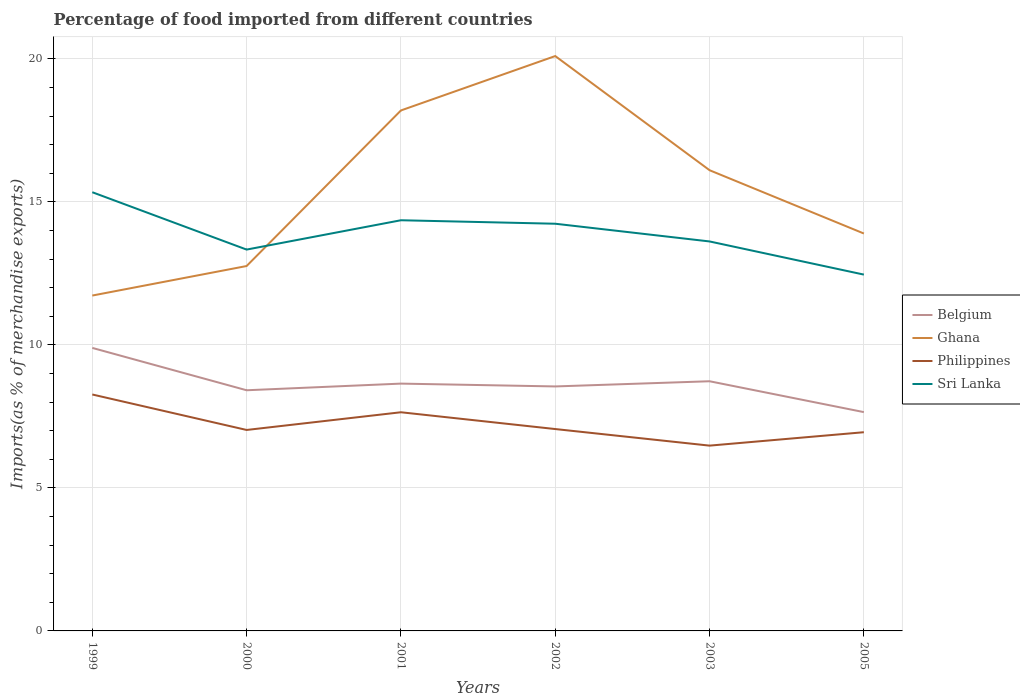Is the number of lines equal to the number of legend labels?
Offer a terse response. Yes. Across all years, what is the maximum percentage of imports to different countries in Ghana?
Provide a short and direct response. 11.73. In which year was the percentage of imports to different countries in Belgium maximum?
Your response must be concise. 2005. What is the total percentage of imports to different countries in Ghana in the graph?
Give a very brief answer. -4.38. What is the difference between the highest and the second highest percentage of imports to different countries in Ghana?
Your response must be concise. 8.37. What is the difference between the highest and the lowest percentage of imports to different countries in Belgium?
Offer a terse response. 2. How many lines are there?
Keep it short and to the point. 4. What is the difference between two consecutive major ticks on the Y-axis?
Provide a succinct answer. 5. Are the values on the major ticks of Y-axis written in scientific E-notation?
Keep it short and to the point. No. Does the graph contain any zero values?
Make the answer very short. No. What is the title of the graph?
Offer a very short reply. Percentage of food imported from different countries. Does "Albania" appear as one of the legend labels in the graph?
Your answer should be very brief. No. What is the label or title of the X-axis?
Provide a short and direct response. Years. What is the label or title of the Y-axis?
Provide a short and direct response. Imports(as % of merchandise exports). What is the Imports(as % of merchandise exports) of Belgium in 1999?
Keep it short and to the point. 9.9. What is the Imports(as % of merchandise exports) of Ghana in 1999?
Keep it short and to the point. 11.73. What is the Imports(as % of merchandise exports) in Philippines in 1999?
Provide a succinct answer. 8.27. What is the Imports(as % of merchandise exports) of Sri Lanka in 1999?
Provide a short and direct response. 15.34. What is the Imports(as % of merchandise exports) of Belgium in 2000?
Your answer should be compact. 8.42. What is the Imports(as % of merchandise exports) in Ghana in 2000?
Keep it short and to the point. 12.76. What is the Imports(as % of merchandise exports) of Philippines in 2000?
Your response must be concise. 7.03. What is the Imports(as % of merchandise exports) in Sri Lanka in 2000?
Your response must be concise. 13.33. What is the Imports(as % of merchandise exports) of Belgium in 2001?
Give a very brief answer. 8.65. What is the Imports(as % of merchandise exports) in Ghana in 2001?
Give a very brief answer. 18.2. What is the Imports(as % of merchandise exports) in Philippines in 2001?
Your answer should be compact. 7.65. What is the Imports(as % of merchandise exports) of Sri Lanka in 2001?
Offer a terse response. 14.36. What is the Imports(as % of merchandise exports) of Belgium in 2002?
Ensure brevity in your answer.  8.55. What is the Imports(as % of merchandise exports) of Ghana in 2002?
Offer a terse response. 20.1. What is the Imports(as % of merchandise exports) of Philippines in 2002?
Your response must be concise. 7.06. What is the Imports(as % of merchandise exports) in Sri Lanka in 2002?
Offer a very short reply. 14.24. What is the Imports(as % of merchandise exports) in Belgium in 2003?
Provide a succinct answer. 8.73. What is the Imports(as % of merchandise exports) of Ghana in 2003?
Give a very brief answer. 16.11. What is the Imports(as % of merchandise exports) of Philippines in 2003?
Provide a short and direct response. 6.48. What is the Imports(as % of merchandise exports) in Sri Lanka in 2003?
Your response must be concise. 13.62. What is the Imports(as % of merchandise exports) in Belgium in 2005?
Offer a very short reply. 7.65. What is the Imports(as % of merchandise exports) in Ghana in 2005?
Make the answer very short. 13.9. What is the Imports(as % of merchandise exports) in Philippines in 2005?
Give a very brief answer. 6.95. What is the Imports(as % of merchandise exports) of Sri Lanka in 2005?
Keep it short and to the point. 12.46. Across all years, what is the maximum Imports(as % of merchandise exports) of Belgium?
Give a very brief answer. 9.9. Across all years, what is the maximum Imports(as % of merchandise exports) in Ghana?
Offer a very short reply. 20.1. Across all years, what is the maximum Imports(as % of merchandise exports) of Philippines?
Make the answer very short. 8.27. Across all years, what is the maximum Imports(as % of merchandise exports) in Sri Lanka?
Offer a terse response. 15.34. Across all years, what is the minimum Imports(as % of merchandise exports) of Belgium?
Provide a short and direct response. 7.65. Across all years, what is the minimum Imports(as % of merchandise exports) in Ghana?
Your answer should be very brief. 11.73. Across all years, what is the minimum Imports(as % of merchandise exports) of Philippines?
Your answer should be compact. 6.48. Across all years, what is the minimum Imports(as % of merchandise exports) of Sri Lanka?
Ensure brevity in your answer.  12.46. What is the total Imports(as % of merchandise exports) of Belgium in the graph?
Give a very brief answer. 51.89. What is the total Imports(as % of merchandise exports) in Ghana in the graph?
Your answer should be very brief. 92.79. What is the total Imports(as % of merchandise exports) of Philippines in the graph?
Offer a very short reply. 43.43. What is the total Imports(as % of merchandise exports) in Sri Lanka in the graph?
Offer a terse response. 83.35. What is the difference between the Imports(as % of merchandise exports) in Belgium in 1999 and that in 2000?
Your answer should be compact. 1.48. What is the difference between the Imports(as % of merchandise exports) in Ghana in 1999 and that in 2000?
Make the answer very short. -1.03. What is the difference between the Imports(as % of merchandise exports) of Philippines in 1999 and that in 2000?
Provide a short and direct response. 1.24. What is the difference between the Imports(as % of merchandise exports) in Sri Lanka in 1999 and that in 2000?
Your response must be concise. 2.01. What is the difference between the Imports(as % of merchandise exports) of Belgium in 1999 and that in 2001?
Your response must be concise. 1.25. What is the difference between the Imports(as % of merchandise exports) in Ghana in 1999 and that in 2001?
Your answer should be compact. -6.47. What is the difference between the Imports(as % of merchandise exports) in Philippines in 1999 and that in 2001?
Keep it short and to the point. 0.62. What is the difference between the Imports(as % of merchandise exports) in Belgium in 1999 and that in 2002?
Your response must be concise. 1.35. What is the difference between the Imports(as % of merchandise exports) in Ghana in 1999 and that in 2002?
Ensure brevity in your answer.  -8.37. What is the difference between the Imports(as % of merchandise exports) of Philippines in 1999 and that in 2002?
Provide a succinct answer. 1.21. What is the difference between the Imports(as % of merchandise exports) of Sri Lanka in 1999 and that in 2002?
Give a very brief answer. 1.1. What is the difference between the Imports(as % of merchandise exports) in Belgium in 1999 and that in 2003?
Ensure brevity in your answer.  1.17. What is the difference between the Imports(as % of merchandise exports) of Ghana in 1999 and that in 2003?
Give a very brief answer. -4.38. What is the difference between the Imports(as % of merchandise exports) of Philippines in 1999 and that in 2003?
Provide a succinct answer. 1.79. What is the difference between the Imports(as % of merchandise exports) in Sri Lanka in 1999 and that in 2003?
Offer a terse response. 1.72. What is the difference between the Imports(as % of merchandise exports) in Belgium in 1999 and that in 2005?
Offer a terse response. 2.25. What is the difference between the Imports(as % of merchandise exports) in Ghana in 1999 and that in 2005?
Keep it short and to the point. -2.17. What is the difference between the Imports(as % of merchandise exports) of Philippines in 1999 and that in 2005?
Give a very brief answer. 1.32. What is the difference between the Imports(as % of merchandise exports) in Sri Lanka in 1999 and that in 2005?
Your response must be concise. 2.88. What is the difference between the Imports(as % of merchandise exports) of Belgium in 2000 and that in 2001?
Keep it short and to the point. -0.23. What is the difference between the Imports(as % of merchandise exports) of Ghana in 2000 and that in 2001?
Offer a very short reply. -5.44. What is the difference between the Imports(as % of merchandise exports) in Philippines in 2000 and that in 2001?
Make the answer very short. -0.62. What is the difference between the Imports(as % of merchandise exports) in Sri Lanka in 2000 and that in 2001?
Make the answer very short. -1.03. What is the difference between the Imports(as % of merchandise exports) in Belgium in 2000 and that in 2002?
Make the answer very short. -0.13. What is the difference between the Imports(as % of merchandise exports) in Ghana in 2000 and that in 2002?
Provide a succinct answer. -7.34. What is the difference between the Imports(as % of merchandise exports) in Philippines in 2000 and that in 2002?
Offer a very short reply. -0.03. What is the difference between the Imports(as % of merchandise exports) of Sri Lanka in 2000 and that in 2002?
Your answer should be compact. -0.9. What is the difference between the Imports(as % of merchandise exports) in Belgium in 2000 and that in 2003?
Provide a succinct answer. -0.32. What is the difference between the Imports(as % of merchandise exports) of Ghana in 2000 and that in 2003?
Keep it short and to the point. -3.35. What is the difference between the Imports(as % of merchandise exports) of Philippines in 2000 and that in 2003?
Ensure brevity in your answer.  0.55. What is the difference between the Imports(as % of merchandise exports) in Sri Lanka in 2000 and that in 2003?
Provide a succinct answer. -0.28. What is the difference between the Imports(as % of merchandise exports) of Belgium in 2000 and that in 2005?
Provide a short and direct response. 0.76. What is the difference between the Imports(as % of merchandise exports) of Ghana in 2000 and that in 2005?
Your answer should be compact. -1.14. What is the difference between the Imports(as % of merchandise exports) in Philippines in 2000 and that in 2005?
Offer a terse response. 0.08. What is the difference between the Imports(as % of merchandise exports) in Sri Lanka in 2000 and that in 2005?
Your answer should be compact. 0.87. What is the difference between the Imports(as % of merchandise exports) in Belgium in 2001 and that in 2002?
Offer a terse response. 0.1. What is the difference between the Imports(as % of merchandise exports) of Ghana in 2001 and that in 2002?
Your response must be concise. -1.9. What is the difference between the Imports(as % of merchandise exports) of Philippines in 2001 and that in 2002?
Provide a succinct answer. 0.59. What is the difference between the Imports(as % of merchandise exports) of Sri Lanka in 2001 and that in 2002?
Provide a short and direct response. 0.12. What is the difference between the Imports(as % of merchandise exports) of Belgium in 2001 and that in 2003?
Offer a very short reply. -0.08. What is the difference between the Imports(as % of merchandise exports) of Ghana in 2001 and that in 2003?
Your answer should be compact. 2.09. What is the difference between the Imports(as % of merchandise exports) of Sri Lanka in 2001 and that in 2003?
Your answer should be very brief. 0.74. What is the difference between the Imports(as % of merchandise exports) in Belgium in 2001 and that in 2005?
Ensure brevity in your answer.  1. What is the difference between the Imports(as % of merchandise exports) of Ghana in 2001 and that in 2005?
Offer a terse response. 4.3. What is the difference between the Imports(as % of merchandise exports) in Philippines in 2001 and that in 2005?
Make the answer very short. 0.7. What is the difference between the Imports(as % of merchandise exports) of Sri Lanka in 2001 and that in 2005?
Your answer should be compact. 1.9. What is the difference between the Imports(as % of merchandise exports) in Belgium in 2002 and that in 2003?
Make the answer very short. -0.18. What is the difference between the Imports(as % of merchandise exports) in Ghana in 2002 and that in 2003?
Your answer should be very brief. 3.99. What is the difference between the Imports(as % of merchandise exports) of Philippines in 2002 and that in 2003?
Provide a succinct answer. 0.58. What is the difference between the Imports(as % of merchandise exports) of Sri Lanka in 2002 and that in 2003?
Offer a very short reply. 0.62. What is the difference between the Imports(as % of merchandise exports) of Belgium in 2002 and that in 2005?
Provide a short and direct response. 0.9. What is the difference between the Imports(as % of merchandise exports) in Ghana in 2002 and that in 2005?
Ensure brevity in your answer.  6.21. What is the difference between the Imports(as % of merchandise exports) in Philippines in 2002 and that in 2005?
Offer a very short reply. 0.11. What is the difference between the Imports(as % of merchandise exports) in Sri Lanka in 2002 and that in 2005?
Your answer should be compact. 1.78. What is the difference between the Imports(as % of merchandise exports) of Belgium in 2003 and that in 2005?
Give a very brief answer. 1.08. What is the difference between the Imports(as % of merchandise exports) of Ghana in 2003 and that in 2005?
Offer a terse response. 2.21. What is the difference between the Imports(as % of merchandise exports) in Philippines in 2003 and that in 2005?
Your response must be concise. -0.47. What is the difference between the Imports(as % of merchandise exports) in Sri Lanka in 2003 and that in 2005?
Your answer should be very brief. 1.16. What is the difference between the Imports(as % of merchandise exports) in Belgium in 1999 and the Imports(as % of merchandise exports) in Ghana in 2000?
Keep it short and to the point. -2.86. What is the difference between the Imports(as % of merchandise exports) of Belgium in 1999 and the Imports(as % of merchandise exports) of Philippines in 2000?
Your answer should be very brief. 2.87. What is the difference between the Imports(as % of merchandise exports) of Belgium in 1999 and the Imports(as % of merchandise exports) of Sri Lanka in 2000?
Provide a succinct answer. -3.44. What is the difference between the Imports(as % of merchandise exports) of Ghana in 1999 and the Imports(as % of merchandise exports) of Philippines in 2000?
Your answer should be very brief. 4.7. What is the difference between the Imports(as % of merchandise exports) in Ghana in 1999 and the Imports(as % of merchandise exports) in Sri Lanka in 2000?
Make the answer very short. -1.61. What is the difference between the Imports(as % of merchandise exports) in Philippines in 1999 and the Imports(as % of merchandise exports) in Sri Lanka in 2000?
Keep it short and to the point. -5.07. What is the difference between the Imports(as % of merchandise exports) in Belgium in 1999 and the Imports(as % of merchandise exports) in Ghana in 2001?
Provide a succinct answer. -8.3. What is the difference between the Imports(as % of merchandise exports) of Belgium in 1999 and the Imports(as % of merchandise exports) of Philippines in 2001?
Ensure brevity in your answer.  2.25. What is the difference between the Imports(as % of merchandise exports) of Belgium in 1999 and the Imports(as % of merchandise exports) of Sri Lanka in 2001?
Make the answer very short. -4.46. What is the difference between the Imports(as % of merchandise exports) of Ghana in 1999 and the Imports(as % of merchandise exports) of Philippines in 2001?
Ensure brevity in your answer.  4.08. What is the difference between the Imports(as % of merchandise exports) of Ghana in 1999 and the Imports(as % of merchandise exports) of Sri Lanka in 2001?
Make the answer very short. -2.63. What is the difference between the Imports(as % of merchandise exports) in Philippines in 1999 and the Imports(as % of merchandise exports) in Sri Lanka in 2001?
Make the answer very short. -6.09. What is the difference between the Imports(as % of merchandise exports) in Belgium in 1999 and the Imports(as % of merchandise exports) in Ghana in 2002?
Provide a short and direct response. -10.21. What is the difference between the Imports(as % of merchandise exports) in Belgium in 1999 and the Imports(as % of merchandise exports) in Philippines in 2002?
Offer a very short reply. 2.84. What is the difference between the Imports(as % of merchandise exports) in Belgium in 1999 and the Imports(as % of merchandise exports) in Sri Lanka in 2002?
Give a very brief answer. -4.34. What is the difference between the Imports(as % of merchandise exports) of Ghana in 1999 and the Imports(as % of merchandise exports) of Philippines in 2002?
Make the answer very short. 4.67. What is the difference between the Imports(as % of merchandise exports) of Ghana in 1999 and the Imports(as % of merchandise exports) of Sri Lanka in 2002?
Your response must be concise. -2.51. What is the difference between the Imports(as % of merchandise exports) of Philippines in 1999 and the Imports(as % of merchandise exports) of Sri Lanka in 2002?
Offer a terse response. -5.97. What is the difference between the Imports(as % of merchandise exports) in Belgium in 1999 and the Imports(as % of merchandise exports) in Ghana in 2003?
Your answer should be compact. -6.21. What is the difference between the Imports(as % of merchandise exports) of Belgium in 1999 and the Imports(as % of merchandise exports) of Philippines in 2003?
Offer a terse response. 3.42. What is the difference between the Imports(as % of merchandise exports) of Belgium in 1999 and the Imports(as % of merchandise exports) of Sri Lanka in 2003?
Your answer should be very brief. -3.72. What is the difference between the Imports(as % of merchandise exports) of Ghana in 1999 and the Imports(as % of merchandise exports) of Philippines in 2003?
Give a very brief answer. 5.25. What is the difference between the Imports(as % of merchandise exports) in Ghana in 1999 and the Imports(as % of merchandise exports) in Sri Lanka in 2003?
Keep it short and to the point. -1.89. What is the difference between the Imports(as % of merchandise exports) in Philippines in 1999 and the Imports(as % of merchandise exports) in Sri Lanka in 2003?
Ensure brevity in your answer.  -5.35. What is the difference between the Imports(as % of merchandise exports) in Belgium in 1999 and the Imports(as % of merchandise exports) in Ghana in 2005?
Ensure brevity in your answer.  -4. What is the difference between the Imports(as % of merchandise exports) in Belgium in 1999 and the Imports(as % of merchandise exports) in Philippines in 2005?
Give a very brief answer. 2.95. What is the difference between the Imports(as % of merchandise exports) of Belgium in 1999 and the Imports(as % of merchandise exports) of Sri Lanka in 2005?
Your answer should be very brief. -2.56. What is the difference between the Imports(as % of merchandise exports) in Ghana in 1999 and the Imports(as % of merchandise exports) in Philippines in 2005?
Keep it short and to the point. 4.78. What is the difference between the Imports(as % of merchandise exports) in Ghana in 1999 and the Imports(as % of merchandise exports) in Sri Lanka in 2005?
Make the answer very short. -0.73. What is the difference between the Imports(as % of merchandise exports) in Philippines in 1999 and the Imports(as % of merchandise exports) in Sri Lanka in 2005?
Provide a short and direct response. -4.19. What is the difference between the Imports(as % of merchandise exports) in Belgium in 2000 and the Imports(as % of merchandise exports) in Ghana in 2001?
Provide a short and direct response. -9.78. What is the difference between the Imports(as % of merchandise exports) of Belgium in 2000 and the Imports(as % of merchandise exports) of Philippines in 2001?
Offer a terse response. 0.77. What is the difference between the Imports(as % of merchandise exports) in Belgium in 2000 and the Imports(as % of merchandise exports) in Sri Lanka in 2001?
Provide a succinct answer. -5.94. What is the difference between the Imports(as % of merchandise exports) of Ghana in 2000 and the Imports(as % of merchandise exports) of Philippines in 2001?
Offer a terse response. 5.11. What is the difference between the Imports(as % of merchandise exports) of Ghana in 2000 and the Imports(as % of merchandise exports) of Sri Lanka in 2001?
Offer a terse response. -1.6. What is the difference between the Imports(as % of merchandise exports) in Philippines in 2000 and the Imports(as % of merchandise exports) in Sri Lanka in 2001?
Offer a terse response. -7.33. What is the difference between the Imports(as % of merchandise exports) of Belgium in 2000 and the Imports(as % of merchandise exports) of Ghana in 2002?
Give a very brief answer. -11.69. What is the difference between the Imports(as % of merchandise exports) of Belgium in 2000 and the Imports(as % of merchandise exports) of Philippines in 2002?
Make the answer very short. 1.36. What is the difference between the Imports(as % of merchandise exports) of Belgium in 2000 and the Imports(as % of merchandise exports) of Sri Lanka in 2002?
Make the answer very short. -5.82. What is the difference between the Imports(as % of merchandise exports) in Ghana in 2000 and the Imports(as % of merchandise exports) in Philippines in 2002?
Your answer should be compact. 5.7. What is the difference between the Imports(as % of merchandise exports) in Ghana in 2000 and the Imports(as % of merchandise exports) in Sri Lanka in 2002?
Make the answer very short. -1.48. What is the difference between the Imports(as % of merchandise exports) in Philippines in 2000 and the Imports(as % of merchandise exports) in Sri Lanka in 2002?
Your answer should be very brief. -7.21. What is the difference between the Imports(as % of merchandise exports) in Belgium in 2000 and the Imports(as % of merchandise exports) in Ghana in 2003?
Make the answer very short. -7.69. What is the difference between the Imports(as % of merchandise exports) of Belgium in 2000 and the Imports(as % of merchandise exports) of Philippines in 2003?
Offer a very short reply. 1.94. What is the difference between the Imports(as % of merchandise exports) of Belgium in 2000 and the Imports(as % of merchandise exports) of Sri Lanka in 2003?
Your answer should be compact. -5.2. What is the difference between the Imports(as % of merchandise exports) in Ghana in 2000 and the Imports(as % of merchandise exports) in Philippines in 2003?
Ensure brevity in your answer.  6.28. What is the difference between the Imports(as % of merchandise exports) of Ghana in 2000 and the Imports(as % of merchandise exports) of Sri Lanka in 2003?
Keep it short and to the point. -0.86. What is the difference between the Imports(as % of merchandise exports) in Philippines in 2000 and the Imports(as % of merchandise exports) in Sri Lanka in 2003?
Your response must be concise. -6.59. What is the difference between the Imports(as % of merchandise exports) in Belgium in 2000 and the Imports(as % of merchandise exports) in Ghana in 2005?
Ensure brevity in your answer.  -5.48. What is the difference between the Imports(as % of merchandise exports) of Belgium in 2000 and the Imports(as % of merchandise exports) of Philippines in 2005?
Your response must be concise. 1.47. What is the difference between the Imports(as % of merchandise exports) in Belgium in 2000 and the Imports(as % of merchandise exports) in Sri Lanka in 2005?
Your answer should be compact. -4.04. What is the difference between the Imports(as % of merchandise exports) in Ghana in 2000 and the Imports(as % of merchandise exports) in Philippines in 2005?
Provide a succinct answer. 5.81. What is the difference between the Imports(as % of merchandise exports) of Ghana in 2000 and the Imports(as % of merchandise exports) of Sri Lanka in 2005?
Ensure brevity in your answer.  0.3. What is the difference between the Imports(as % of merchandise exports) in Philippines in 2000 and the Imports(as % of merchandise exports) in Sri Lanka in 2005?
Ensure brevity in your answer.  -5.43. What is the difference between the Imports(as % of merchandise exports) of Belgium in 2001 and the Imports(as % of merchandise exports) of Ghana in 2002?
Provide a short and direct response. -11.45. What is the difference between the Imports(as % of merchandise exports) in Belgium in 2001 and the Imports(as % of merchandise exports) in Philippines in 2002?
Provide a short and direct response. 1.59. What is the difference between the Imports(as % of merchandise exports) of Belgium in 2001 and the Imports(as % of merchandise exports) of Sri Lanka in 2002?
Give a very brief answer. -5.59. What is the difference between the Imports(as % of merchandise exports) of Ghana in 2001 and the Imports(as % of merchandise exports) of Philippines in 2002?
Ensure brevity in your answer.  11.14. What is the difference between the Imports(as % of merchandise exports) of Ghana in 2001 and the Imports(as % of merchandise exports) of Sri Lanka in 2002?
Your answer should be very brief. 3.96. What is the difference between the Imports(as % of merchandise exports) in Philippines in 2001 and the Imports(as % of merchandise exports) in Sri Lanka in 2002?
Offer a very short reply. -6.59. What is the difference between the Imports(as % of merchandise exports) of Belgium in 2001 and the Imports(as % of merchandise exports) of Ghana in 2003?
Keep it short and to the point. -7.46. What is the difference between the Imports(as % of merchandise exports) in Belgium in 2001 and the Imports(as % of merchandise exports) in Philippines in 2003?
Your answer should be very brief. 2.17. What is the difference between the Imports(as % of merchandise exports) in Belgium in 2001 and the Imports(as % of merchandise exports) in Sri Lanka in 2003?
Give a very brief answer. -4.97. What is the difference between the Imports(as % of merchandise exports) of Ghana in 2001 and the Imports(as % of merchandise exports) of Philippines in 2003?
Provide a short and direct response. 11.72. What is the difference between the Imports(as % of merchandise exports) of Ghana in 2001 and the Imports(as % of merchandise exports) of Sri Lanka in 2003?
Offer a terse response. 4.58. What is the difference between the Imports(as % of merchandise exports) in Philippines in 2001 and the Imports(as % of merchandise exports) in Sri Lanka in 2003?
Offer a very short reply. -5.97. What is the difference between the Imports(as % of merchandise exports) in Belgium in 2001 and the Imports(as % of merchandise exports) in Ghana in 2005?
Ensure brevity in your answer.  -5.25. What is the difference between the Imports(as % of merchandise exports) of Belgium in 2001 and the Imports(as % of merchandise exports) of Philippines in 2005?
Make the answer very short. 1.7. What is the difference between the Imports(as % of merchandise exports) in Belgium in 2001 and the Imports(as % of merchandise exports) in Sri Lanka in 2005?
Offer a very short reply. -3.81. What is the difference between the Imports(as % of merchandise exports) of Ghana in 2001 and the Imports(as % of merchandise exports) of Philippines in 2005?
Give a very brief answer. 11.25. What is the difference between the Imports(as % of merchandise exports) of Ghana in 2001 and the Imports(as % of merchandise exports) of Sri Lanka in 2005?
Offer a terse response. 5.74. What is the difference between the Imports(as % of merchandise exports) of Philippines in 2001 and the Imports(as % of merchandise exports) of Sri Lanka in 2005?
Your answer should be very brief. -4.81. What is the difference between the Imports(as % of merchandise exports) of Belgium in 2002 and the Imports(as % of merchandise exports) of Ghana in 2003?
Provide a short and direct response. -7.56. What is the difference between the Imports(as % of merchandise exports) of Belgium in 2002 and the Imports(as % of merchandise exports) of Philippines in 2003?
Provide a short and direct response. 2.07. What is the difference between the Imports(as % of merchandise exports) in Belgium in 2002 and the Imports(as % of merchandise exports) in Sri Lanka in 2003?
Your answer should be very brief. -5.07. What is the difference between the Imports(as % of merchandise exports) in Ghana in 2002 and the Imports(as % of merchandise exports) in Philippines in 2003?
Offer a very short reply. 13.62. What is the difference between the Imports(as % of merchandise exports) of Ghana in 2002 and the Imports(as % of merchandise exports) of Sri Lanka in 2003?
Ensure brevity in your answer.  6.48. What is the difference between the Imports(as % of merchandise exports) of Philippines in 2002 and the Imports(as % of merchandise exports) of Sri Lanka in 2003?
Keep it short and to the point. -6.56. What is the difference between the Imports(as % of merchandise exports) of Belgium in 2002 and the Imports(as % of merchandise exports) of Ghana in 2005?
Offer a very short reply. -5.35. What is the difference between the Imports(as % of merchandise exports) in Belgium in 2002 and the Imports(as % of merchandise exports) in Philippines in 2005?
Your answer should be very brief. 1.6. What is the difference between the Imports(as % of merchandise exports) in Belgium in 2002 and the Imports(as % of merchandise exports) in Sri Lanka in 2005?
Ensure brevity in your answer.  -3.91. What is the difference between the Imports(as % of merchandise exports) of Ghana in 2002 and the Imports(as % of merchandise exports) of Philippines in 2005?
Offer a very short reply. 13.15. What is the difference between the Imports(as % of merchandise exports) of Ghana in 2002 and the Imports(as % of merchandise exports) of Sri Lanka in 2005?
Keep it short and to the point. 7.64. What is the difference between the Imports(as % of merchandise exports) of Philippines in 2002 and the Imports(as % of merchandise exports) of Sri Lanka in 2005?
Your answer should be compact. -5.4. What is the difference between the Imports(as % of merchandise exports) in Belgium in 2003 and the Imports(as % of merchandise exports) in Ghana in 2005?
Ensure brevity in your answer.  -5.17. What is the difference between the Imports(as % of merchandise exports) of Belgium in 2003 and the Imports(as % of merchandise exports) of Philippines in 2005?
Provide a succinct answer. 1.78. What is the difference between the Imports(as % of merchandise exports) of Belgium in 2003 and the Imports(as % of merchandise exports) of Sri Lanka in 2005?
Ensure brevity in your answer.  -3.73. What is the difference between the Imports(as % of merchandise exports) of Ghana in 2003 and the Imports(as % of merchandise exports) of Philippines in 2005?
Offer a terse response. 9.16. What is the difference between the Imports(as % of merchandise exports) of Ghana in 2003 and the Imports(as % of merchandise exports) of Sri Lanka in 2005?
Your response must be concise. 3.65. What is the difference between the Imports(as % of merchandise exports) of Philippines in 2003 and the Imports(as % of merchandise exports) of Sri Lanka in 2005?
Your answer should be very brief. -5.98. What is the average Imports(as % of merchandise exports) in Belgium per year?
Your response must be concise. 8.65. What is the average Imports(as % of merchandise exports) in Ghana per year?
Provide a succinct answer. 15.47. What is the average Imports(as % of merchandise exports) in Philippines per year?
Offer a very short reply. 7.24. What is the average Imports(as % of merchandise exports) of Sri Lanka per year?
Provide a short and direct response. 13.89. In the year 1999, what is the difference between the Imports(as % of merchandise exports) in Belgium and Imports(as % of merchandise exports) in Ghana?
Make the answer very short. -1.83. In the year 1999, what is the difference between the Imports(as % of merchandise exports) of Belgium and Imports(as % of merchandise exports) of Philippines?
Provide a succinct answer. 1.63. In the year 1999, what is the difference between the Imports(as % of merchandise exports) of Belgium and Imports(as % of merchandise exports) of Sri Lanka?
Provide a short and direct response. -5.44. In the year 1999, what is the difference between the Imports(as % of merchandise exports) of Ghana and Imports(as % of merchandise exports) of Philippines?
Ensure brevity in your answer.  3.46. In the year 1999, what is the difference between the Imports(as % of merchandise exports) in Ghana and Imports(as % of merchandise exports) in Sri Lanka?
Your answer should be very brief. -3.61. In the year 1999, what is the difference between the Imports(as % of merchandise exports) in Philippines and Imports(as % of merchandise exports) in Sri Lanka?
Offer a terse response. -7.07. In the year 2000, what is the difference between the Imports(as % of merchandise exports) of Belgium and Imports(as % of merchandise exports) of Ghana?
Make the answer very short. -4.34. In the year 2000, what is the difference between the Imports(as % of merchandise exports) in Belgium and Imports(as % of merchandise exports) in Philippines?
Offer a terse response. 1.39. In the year 2000, what is the difference between the Imports(as % of merchandise exports) in Belgium and Imports(as % of merchandise exports) in Sri Lanka?
Your answer should be compact. -4.92. In the year 2000, what is the difference between the Imports(as % of merchandise exports) of Ghana and Imports(as % of merchandise exports) of Philippines?
Provide a short and direct response. 5.73. In the year 2000, what is the difference between the Imports(as % of merchandise exports) in Ghana and Imports(as % of merchandise exports) in Sri Lanka?
Provide a succinct answer. -0.57. In the year 2000, what is the difference between the Imports(as % of merchandise exports) of Philippines and Imports(as % of merchandise exports) of Sri Lanka?
Provide a succinct answer. -6.31. In the year 2001, what is the difference between the Imports(as % of merchandise exports) of Belgium and Imports(as % of merchandise exports) of Ghana?
Give a very brief answer. -9.55. In the year 2001, what is the difference between the Imports(as % of merchandise exports) of Belgium and Imports(as % of merchandise exports) of Philippines?
Provide a succinct answer. 1. In the year 2001, what is the difference between the Imports(as % of merchandise exports) of Belgium and Imports(as % of merchandise exports) of Sri Lanka?
Give a very brief answer. -5.71. In the year 2001, what is the difference between the Imports(as % of merchandise exports) in Ghana and Imports(as % of merchandise exports) in Philippines?
Ensure brevity in your answer.  10.55. In the year 2001, what is the difference between the Imports(as % of merchandise exports) of Ghana and Imports(as % of merchandise exports) of Sri Lanka?
Offer a very short reply. 3.84. In the year 2001, what is the difference between the Imports(as % of merchandise exports) of Philippines and Imports(as % of merchandise exports) of Sri Lanka?
Keep it short and to the point. -6.71. In the year 2002, what is the difference between the Imports(as % of merchandise exports) of Belgium and Imports(as % of merchandise exports) of Ghana?
Offer a terse response. -11.55. In the year 2002, what is the difference between the Imports(as % of merchandise exports) of Belgium and Imports(as % of merchandise exports) of Philippines?
Give a very brief answer. 1.49. In the year 2002, what is the difference between the Imports(as % of merchandise exports) of Belgium and Imports(as % of merchandise exports) of Sri Lanka?
Make the answer very short. -5.69. In the year 2002, what is the difference between the Imports(as % of merchandise exports) in Ghana and Imports(as % of merchandise exports) in Philippines?
Offer a terse response. 13.04. In the year 2002, what is the difference between the Imports(as % of merchandise exports) of Ghana and Imports(as % of merchandise exports) of Sri Lanka?
Make the answer very short. 5.86. In the year 2002, what is the difference between the Imports(as % of merchandise exports) in Philippines and Imports(as % of merchandise exports) in Sri Lanka?
Offer a terse response. -7.18. In the year 2003, what is the difference between the Imports(as % of merchandise exports) of Belgium and Imports(as % of merchandise exports) of Ghana?
Offer a very short reply. -7.38. In the year 2003, what is the difference between the Imports(as % of merchandise exports) of Belgium and Imports(as % of merchandise exports) of Philippines?
Provide a succinct answer. 2.25. In the year 2003, what is the difference between the Imports(as % of merchandise exports) of Belgium and Imports(as % of merchandise exports) of Sri Lanka?
Ensure brevity in your answer.  -4.89. In the year 2003, what is the difference between the Imports(as % of merchandise exports) of Ghana and Imports(as % of merchandise exports) of Philippines?
Ensure brevity in your answer.  9.63. In the year 2003, what is the difference between the Imports(as % of merchandise exports) of Ghana and Imports(as % of merchandise exports) of Sri Lanka?
Give a very brief answer. 2.49. In the year 2003, what is the difference between the Imports(as % of merchandise exports) in Philippines and Imports(as % of merchandise exports) in Sri Lanka?
Provide a succinct answer. -7.14. In the year 2005, what is the difference between the Imports(as % of merchandise exports) in Belgium and Imports(as % of merchandise exports) in Ghana?
Provide a short and direct response. -6.25. In the year 2005, what is the difference between the Imports(as % of merchandise exports) of Belgium and Imports(as % of merchandise exports) of Philippines?
Keep it short and to the point. 0.7. In the year 2005, what is the difference between the Imports(as % of merchandise exports) of Belgium and Imports(as % of merchandise exports) of Sri Lanka?
Your answer should be very brief. -4.81. In the year 2005, what is the difference between the Imports(as % of merchandise exports) in Ghana and Imports(as % of merchandise exports) in Philippines?
Keep it short and to the point. 6.95. In the year 2005, what is the difference between the Imports(as % of merchandise exports) in Ghana and Imports(as % of merchandise exports) in Sri Lanka?
Make the answer very short. 1.44. In the year 2005, what is the difference between the Imports(as % of merchandise exports) in Philippines and Imports(as % of merchandise exports) in Sri Lanka?
Your answer should be compact. -5.51. What is the ratio of the Imports(as % of merchandise exports) in Belgium in 1999 to that in 2000?
Your answer should be compact. 1.18. What is the ratio of the Imports(as % of merchandise exports) of Ghana in 1999 to that in 2000?
Offer a very short reply. 0.92. What is the ratio of the Imports(as % of merchandise exports) of Philippines in 1999 to that in 2000?
Keep it short and to the point. 1.18. What is the ratio of the Imports(as % of merchandise exports) in Sri Lanka in 1999 to that in 2000?
Your response must be concise. 1.15. What is the ratio of the Imports(as % of merchandise exports) of Belgium in 1999 to that in 2001?
Provide a succinct answer. 1.14. What is the ratio of the Imports(as % of merchandise exports) in Ghana in 1999 to that in 2001?
Give a very brief answer. 0.64. What is the ratio of the Imports(as % of merchandise exports) of Philippines in 1999 to that in 2001?
Offer a very short reply. 1.08. What is the ratio of the Imports(as % of merchandise exports) of Sri Lanka in 1999 to that in 2001?
Make the answer very short. 1.07. What is the ratio of the Imports(as % of merchandise exports) of Belgium in 1999 to that in 2002?
Offer a very short reply. 1.16. What is the ratio of the Imports(as % of merchandise exports) of Ghana in 1999 to that in 2002?
Make the answer very short. 0.58. What is the ratio of the Imports(as % of merchandise exports) in Philippines in 1999 to that in 2002?
Offer a very short reply. 1.17. What is the ratio of the Imports(as % of merchandise exports) in Sri Lanka in 1999 to that in 2002?
Make the answer very short. 1.08. What is the ratio of the Imports(as % of merchandise exports) in Belgium in 1999 to that in 2003?
Provide a short and direct response. 1.13. What is the ratio of the Imports(as % of merchandise exports) of Ghana in 1999 to that in 2003?
Offer a very short reply. 0.73. What is the ratio of the Imports(as % of merchandise exports) of Philippines in 1999 to that in 2003?
Offer a very short reply. 1.28. What is the ratio of the Imports(as % of merchandise exports) of Sri Lanka in 1999 to that in 2003?
Offer a very short reply. 1.13. What is the ratio of the Imports(as % of merchandise exports) in Belgium in 1999 to that in 2005?
Your answer should be compact. 1.29. What is the ratio of the Imports(as % of merchandise exports) of Ghana in 1999 to that in 2005?
Ensure brevity in your answer.  0.84. What is the ratio of the Imports(as % of merchandise exports) in Philippines in 1999 to that in 2005?
Offer a very short reply. 1.19. What is the ratio of the Imports(as % of merchandise exports) of Sri Lanka in 1999 to that in 2005?
Your answer should be compact. 1.23. What is the ratio of the Imports(as % of merchandise exports) in Belgium in 2000 to that in 2001?
Your answer should be very brief. 0.97. What is the ratio of the Imports(as % of merchandise exports) in Ghana in 2000 to that in 2001?
Your answer should be compact. 0.7. What is the ratio of the Imports(as % of merchandise exports) in Philippines in 2000 to that in 2001?
Provide a short and direct response. 0.92. What is the ratio of the Imports(as % of merchandise exports) of Belgium in 2000 to that in 2002?
Ensure brevity in your answer.  0.98. What is the ratio of the Imports(as % of merchandise exports) of Ghana in 2000 to that in 2002?
Provide a succinct answer. 0.63. What is the ratio of the Imports(as % of merchandise exports) in Sri Lanka in 2000 to that in 2002?
Make the answer very short. 0.94. What is the ratio of the Imports(as % of merchandise exports) of Belgium in 2000 to that in 2003?
Give a very brief answer. 0.96. What is the ratio of the Imports(as % of merchandise exports) in Ghana in 2000 to that in 2003?
Keep it short and to the point. 0.79. What is the ratio of the Imports(as % of merchandise exports) of Philippines in 2000 to that in 2003?
Keep it short and to the point. 1.08. What is the ratio of the Imports(as % of merchandise exports) in Sri Lanka in 2000 to that in 2003?
Make the answer very short. 0.98. What is the ratio of the Imports(as % of merchandise exports) in Belgium in 2000 to that in 2005?
Provide a short and direct response. 1.1. What is the ratio of the Imports(as % of merchandise exports) of Ghana in 2000 to that in 2005?
Keep it short and to the point. 0.92. What is the ratio of the Imports(as % of merchandise exports) in Philippines in 2000 to that in 2005?
Your response must be concise. 1.01. What is the ratio of the Imports(as % of merchandise exports) of Sri Lanka in 2000 to that in 2005?
Offer a terse response. 1.07. What is the ratio of the Imports(as % of merchandise exports) of Belgium in 2001 to that in 2002?
Your answer should be compact. 1.01. What is the ratio of the Imports(as % of merchandise exports) of Ghana in 2001 to that in 2002?
Give a very brief answer. 0.91. What is the ratio of the Imports(as % of merchandise exports) in Philippines in 2001 to that in 2002?
Your response must be concise. 1.08. What is the ratio of the Imports(as % of merchandise exports) in Sri Lanka in 2001 to that in 2002?
Provide a succinct answer. 1.01. What is the ratio of the Imports(as % of merchandise exports) of Belgium in 2001 to that in 2003?
Your answer should be compact. 0.99. What is the ratio of the Imports(as % of merchandise exports) of Ghana in 2001 to that in 2003?
Provide a short and direct response. 1.13. What is the ratio of the Imports(as % of merchandise exports) in Philippines in 2001 to that in 2003?
Give a very brief answer. 1.18. What is the ratio of the Imports(as % of merchandise exports) in Sri Lanka in 2001 to that in 2003?
Your answer should be compact. 1.05. What is the ratio of the Imports(as % of merchandise exports) in Belgium in 2001 to that in 2005?
Provide a succinct answer. 1.13. What is the ratio of the Imports(as % of merchandise exports) of Ghana in 2001 to that in 2005?
Ensure brevity in your answer.  1.31. What is the ratio of the Imports(as % of merchandise exports) of Philippines in 2001 to that in 2005?
Offer a very short reply. 1.1. What is the ratio of the Imports(as % of merchandise exports) of Sri Lanka in 2001 to that in 2005?
Ensure brevity in your answer.  1.15. What is the ratio of the Imports(as % of merchandise exports) in Belgium in 2002 to that in 2003?
Offer a very short reply. 0.98. What is the ratio of the Imports(as % of merchandise exports) of Ghana in 2002 to that in 2003?
Your answer should be very brief. 1.25. What is the ratio of the Imports(as % of merchandise exports) in Philippines in 2002 to that in 2003?
Offer a very short reply. 1.09. What is the ratio of the Imports(as % of merchandise exports) in Sri Lanka in 2002 to that in 2003?
Ensure brevity in your answer.  1.05. What is the ratio of the Imports(as % of merchandise exports) of Belgium in 2002 to that in 2005?
Ensure brevity in your answer.  1.12. What is the ratio of the Imports(as % of merchandise exports) in Ghana in 2002 to that in 2005?
Your response must be concise. 1.45. What is the ratio of the Imports(as % of merchandise exports) in Philippines in 2002 to that in 2005?
Keep it short and to the point. 1.02. What is the ratio of the Imports(as % of merchandise exports) of Sri Lanka in 2002 to that in 2005?
Offer a terse response. 1.14. What is the ratio of the Imports(as % of merchandise exports) of Belgium in 2003 to that in 2005?
Offer a very short reply. 1.14. What is the ratio of the Imports(as % of merchandise exports) in Ghana in 2003 to that in 2005?
Provide a succinct answer. 1.16. What is the ratio of the Imports(as % of merchandise exports) in Philippines in 2003 to that in 2005?
Your response must be concise. 0.93. What is the ratio of the Imports(as % of merchandise exports) of Sri Lanka in 2003 to that in 2005?
Provide a succinct answer. 1.09. What is the difference between the highest and the second highest Imports(as % of merchandise exports) of Belgium?
Offer a very short reply. 1.17. What is the difference between the highest and the second highest Imports(as % of merchandise exports) in Ghana?
Provide a succinct answer. 1.9. What is the difference between the highest and the second highest Imports(as % of merchandise exports) in Philippines?
Your answer should be very brief. 0.62. What is the difference between the highest and the lowest Imports(as % of merchandise exports) of Belgium?
Provide a short and direct response. 2.25. What is the difference between the highest and the lowest Imports(as % of merchandise exports) in Ghana?
Your answer should be very brief. 8.37. What is the difference between the highest and the lowest Imports(as % of merchandise exports) in Philippines?
Keep it short and to the point. 1.79. What is the difference between the highest and the lowest Imports(as % of merchandise exports) of Sri Lanka?
Your answer should be very brief. 2.88. 